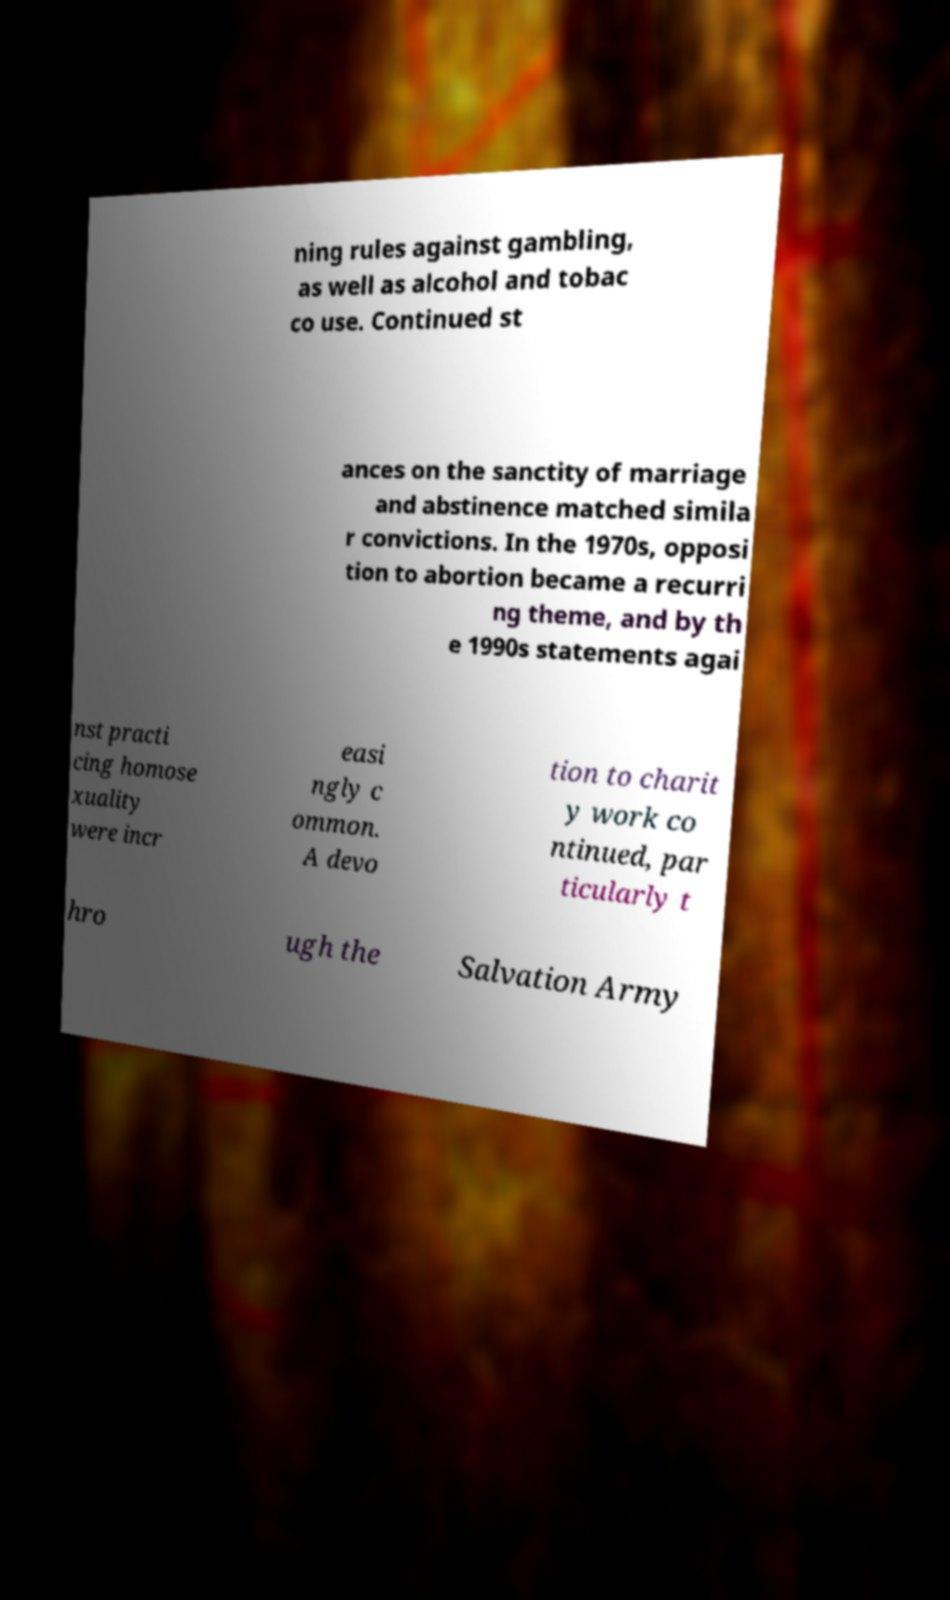Can you read and provide the text displayed in the image?This photo seems to have some interesting text. Can you extract and type it out for me? ning rules against gambling, as well as alcohol and tobac co use. Continued st ances on the sanctity of marriage and abstinence matched simila r convictions. In the 1970s, opposi tion to abortion became a recurri ng theme, and by th e 1990s statements agai nst practi cing homose xuality were incr easi ngly c ommon. A devo tion to charit y work co ntinued, par ticularly t hro ugh the Salvation Army 